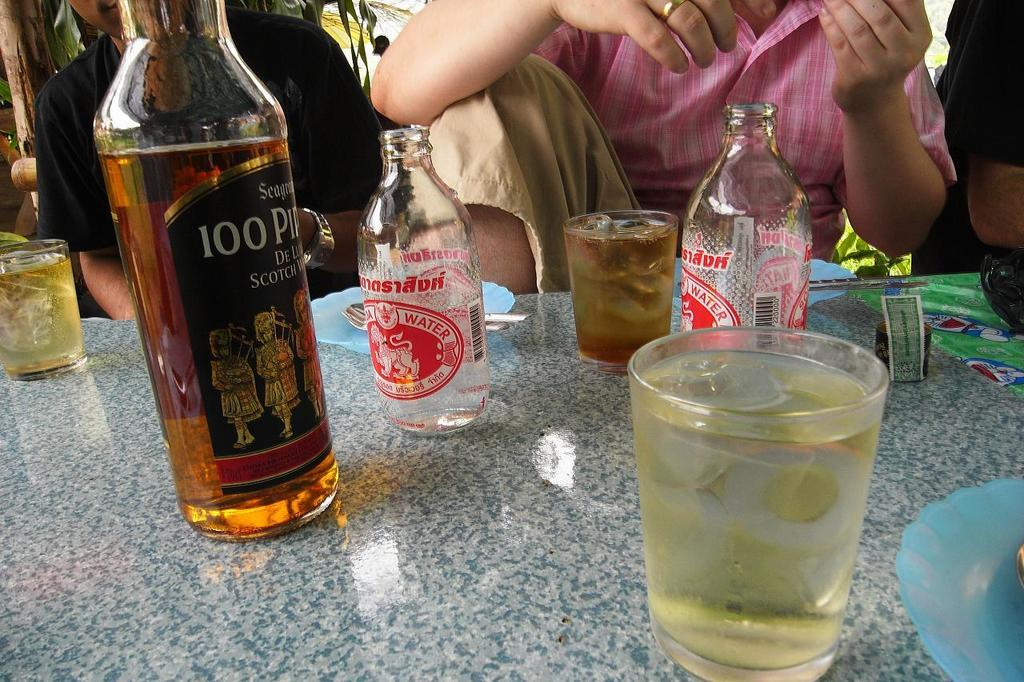<image>
Offer a succinct explanation of the picture presented. A bottle of seagrams on a table with many drinks 